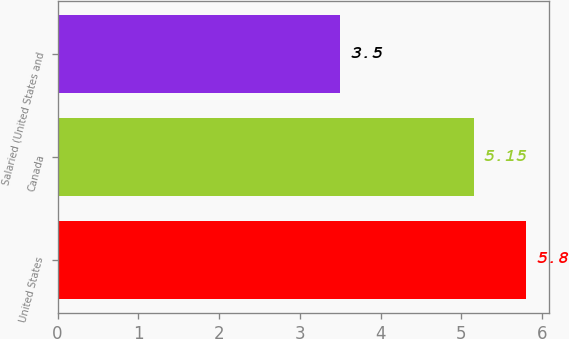Convert chart. <chart><loc_0><loc_0><loc_500><loc_500><bar_chart><fcel>United States<fcel>Canada<fcel>Salaried (United States and<nl><fcel>5.8<fcel>5.15<fcel>3.5<nl></chart> 